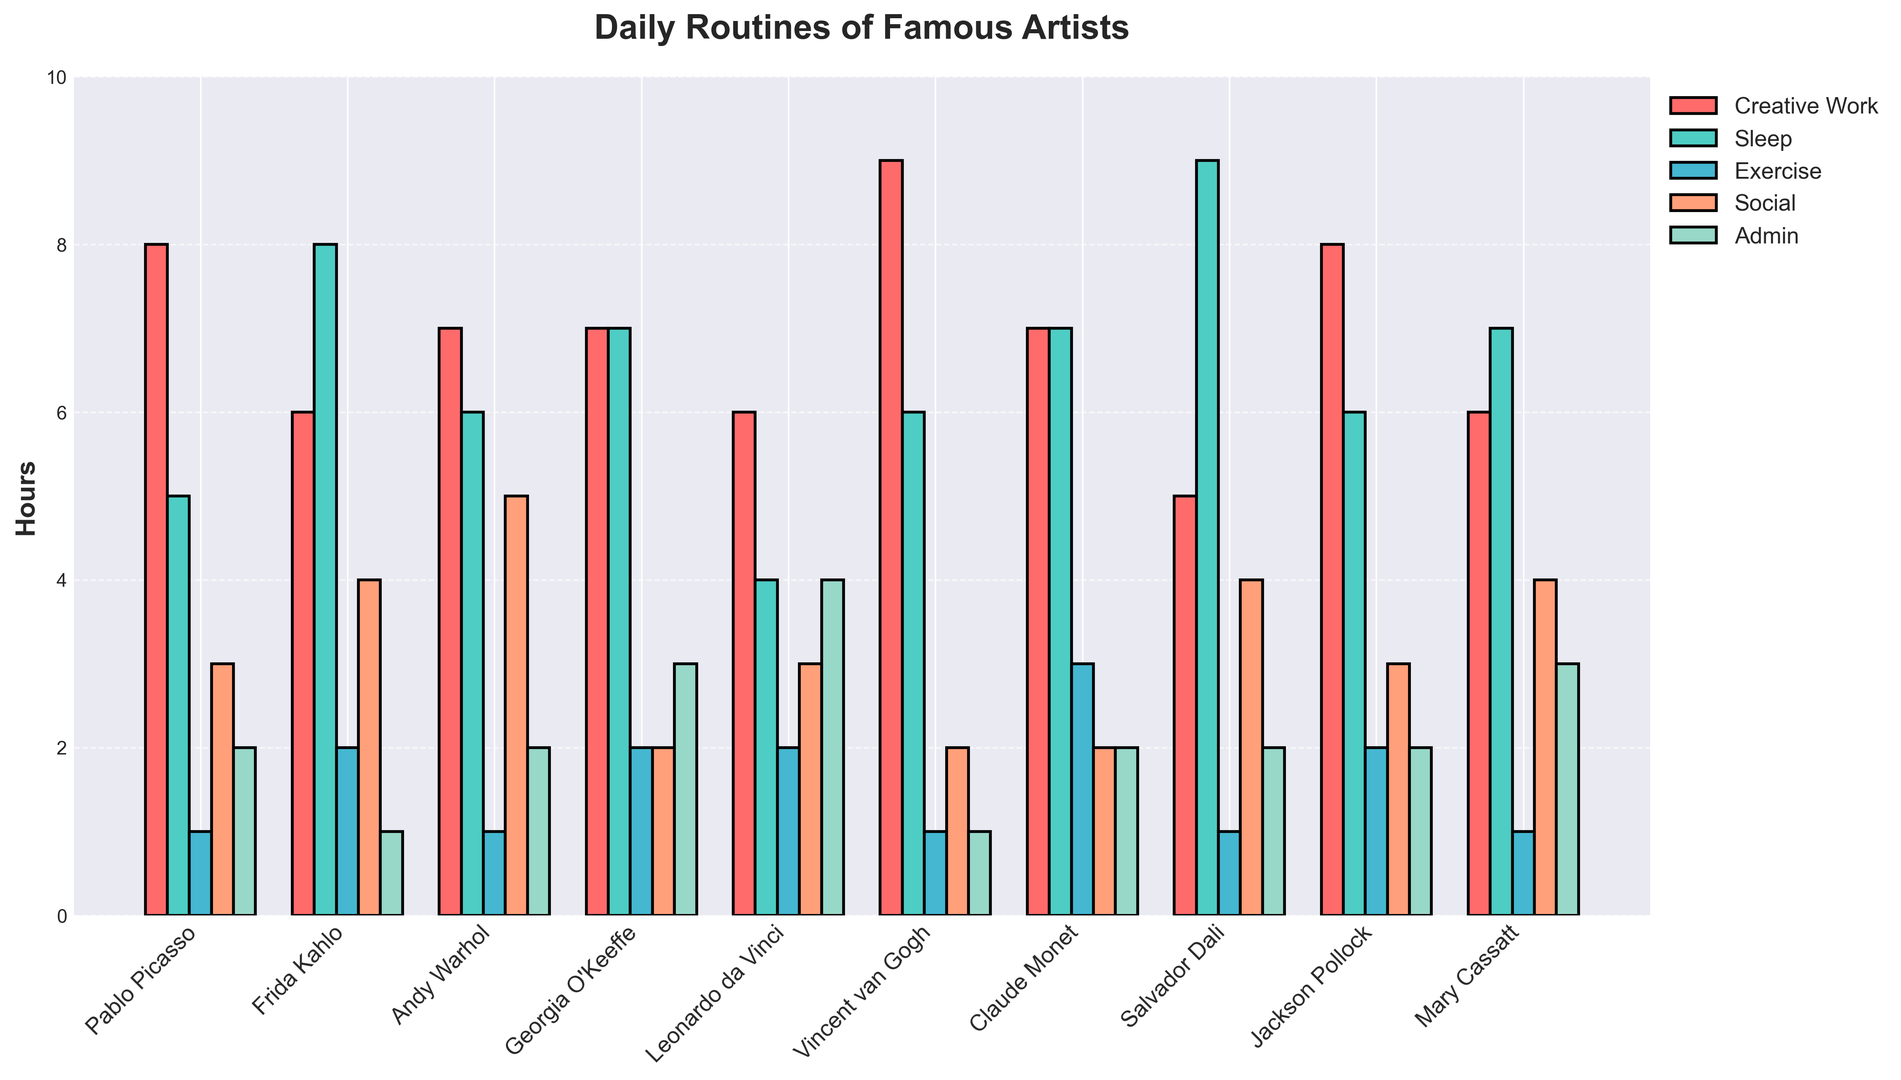What's the total amount of time Pablo Picasso and Vincent van Gogh spent on creative work combined? First, find the hours spent by each: Pablo Picasso (8 hours), Vincent van Gogh (9 hours). Then, sum them up: 8 + 9 = 17 hours.
Answer: 17 hours Which artist spends the most time sleeping? Look at the 'Sleep' bars and find the tallest one. Salvador Dali has the highest sleep bar corresponding to 9 hours.
Answer: Salvador Dali Compare the time Frida Kahlo and Georgia O'Keeffe spend on exercise. Check the length of the exercise bars for both: Frida Kahlo (2 hours), Georgia O'Keeffe (2 hours). Both bars are equal in height.
Answer: Equal Which activity has the most varied time distribution among the artists? Analyze the height variation among the bars for each activity. Creative Work appears to have the most varied distribution with values ranging from 5 to 9 hours.
Answer: Creative Work What is the average time spent on admin work across all artists? Sum the 'Admin' hours for all artists and divide by the number of artists: (2 + 1 + 2 + 3 + 4 + 1 + 2 + 2 + 2 + 3) / 10 = 22 / 10 = 2.2 hours.
Answer: 2.2 hours Which artist has the least variation in time spent across different activities? Look at the bars for each artist and identify which has the least difference among all activity heights. For Georgia O'Keeffe, the variation among Creative Work (7), Sleep (7), Exercise (2), Social (2), and Admin (3) is minimal.
Answer: Georgia O'Keeffe How much more time does Claude Monet spend on exercise compared to Jackson Pollock? Calculate the difference in exercise hours: Claude Monet (3 hours) - Jackson Pollock (2 hours) = 1 hour.
Answer: 1 hour Is there any artist who spends exactly 8 hours on creative work? Examine the Creative Work bars and find if any reach exactly 8 hours. Both Pablo Picasso and Jackson Pollock meet this criterion.
Answer: Pablo Picasso, Jackson Pollock Compare the total time spent on social activities between Andy Warhol and Mary Cassatt. Add up the social hours for both: Andy Warhol (5 hours), Mary Cassatt (4 hours). 5 > 4, hence Andy Warhol spends more time.
Answer: Andy Warhol What's the total amount of time Leonardo da Vinci dedicates to non-creative activities per day? Sum the hours dedicated to Sleep (4), Exercise (2), Social (3), and Admin (4): 4 + 2 + 3 + 4 = 13 hours.
Answer: 13 hours 